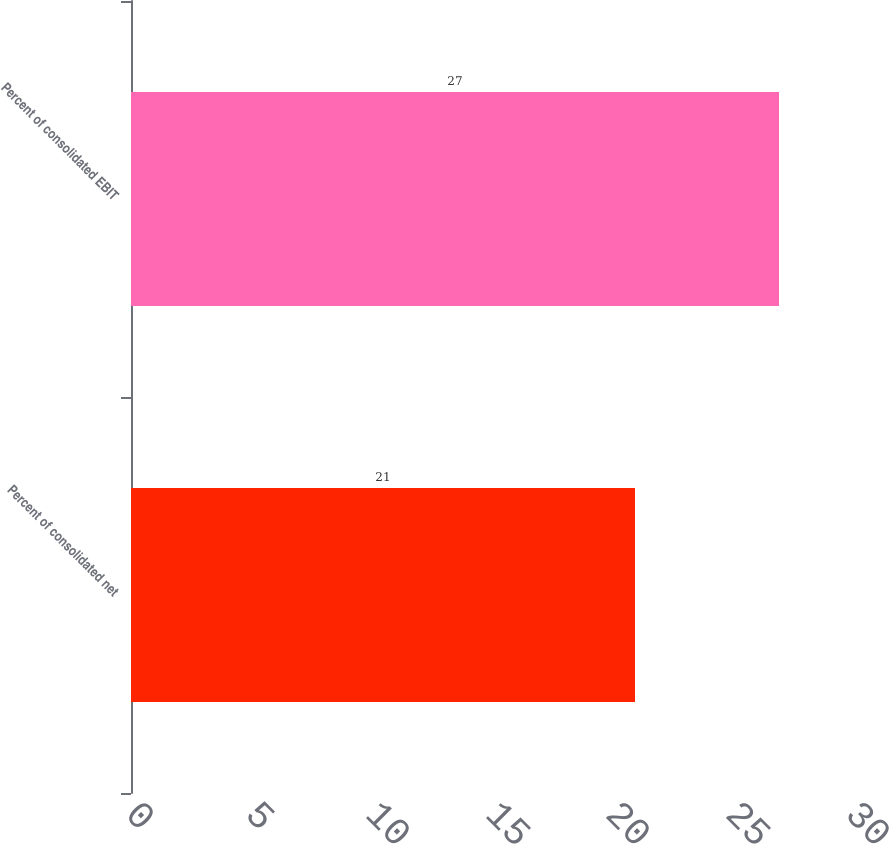Convert chart. <chart><loc_0><loc_0><loc_500><loc_500><bar_chart><fcel>Percent of consolidated net<fcel>Percent of consolidated EBIT<nl><fcel>21<fcel>27<nl></chart> 